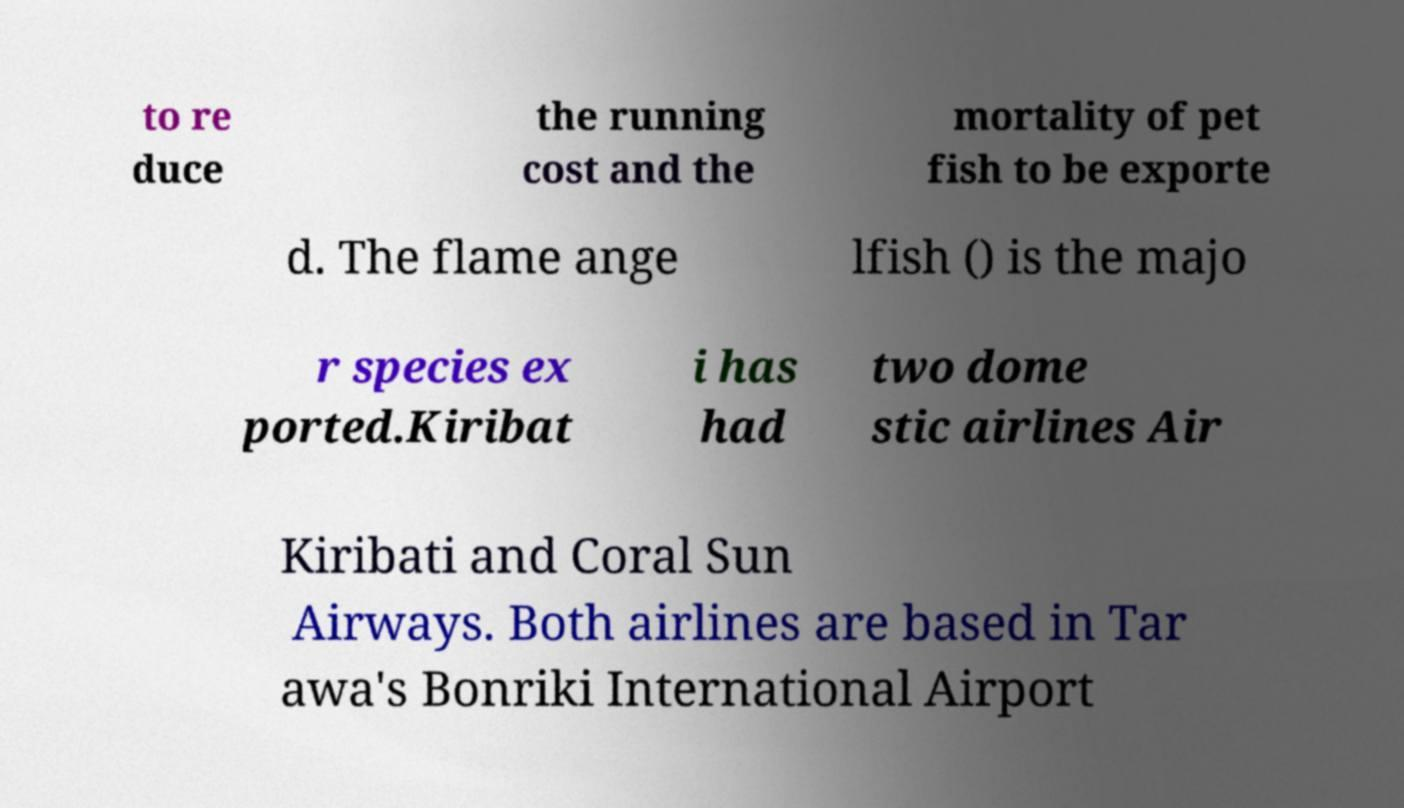Please read and relay the text visible in this image. What does it say? to re duce the running cost and the mortality of pet fish to be exporte d. The flame ange lfish () is the majo r species ex ported.Kiribat i has had two dome stic airlines Air Kiribati and Coral Sun Airways. Both airlines are based in Tar awa's Bonriki International Airport 